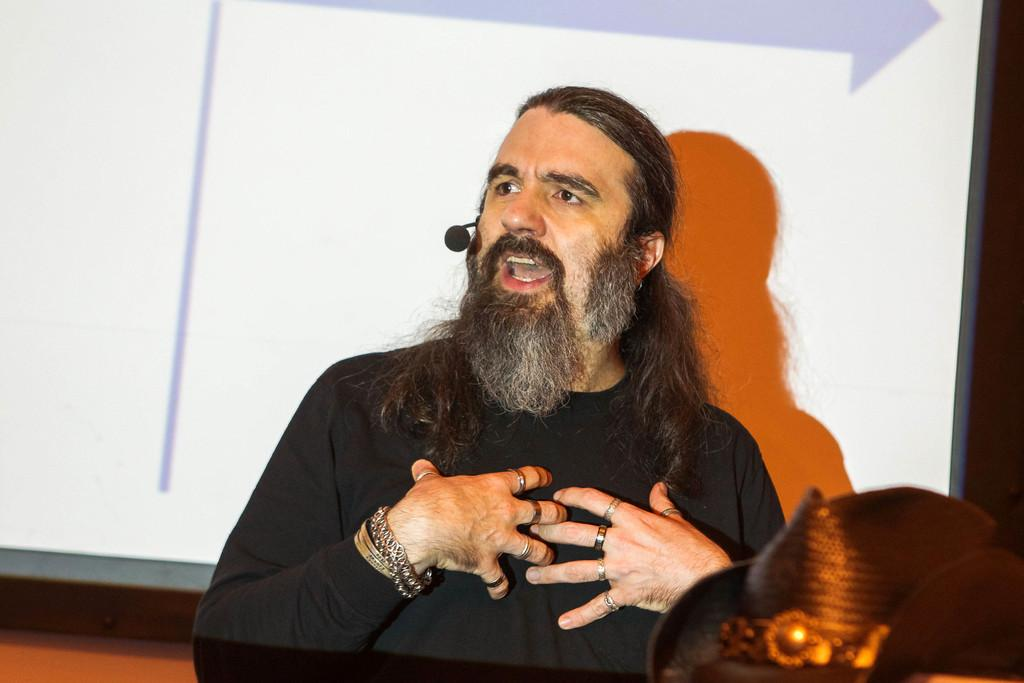What is the man in the image doing? The man is talking. What is the man wearing in the image? The man is wearing a black t-shirt. What object is the man holding in the image? The man is holding a microphone. What can be seen behind the man in the image? There is a screen behind the man. Where is the hat located in the image? The hat is in the bottom right side of the image. What type of agreement is the man signing in the image? There is no agreement or signing activity depicted in the image; the man is talking and holding a microphone. 